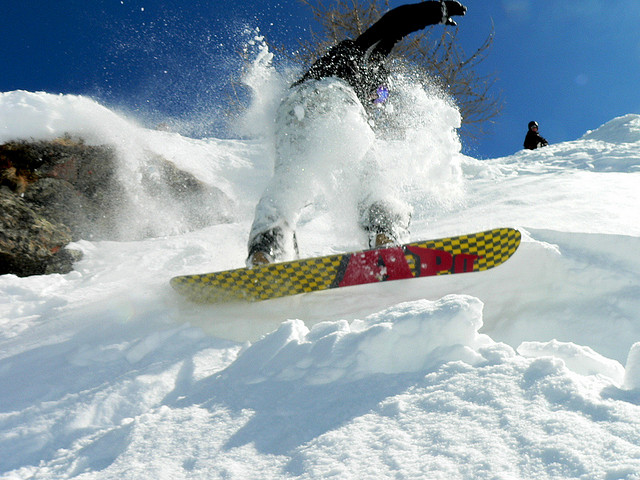<image>How deep is the snow? It is unknown how deep the snow is. It is suggested to be between 1 to 3 feet. How deep is the snow? The snow is very deep. It can be several feet deep. 